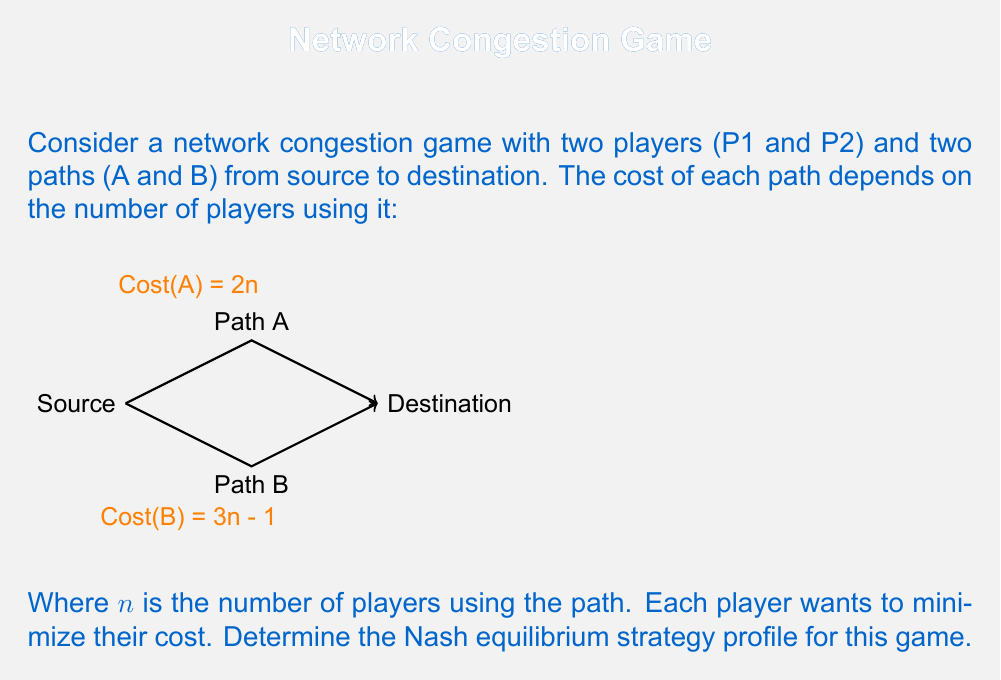Give your solution to this math problem. To find the Nash equilibrium, we need to analyze each player's best response to the other player's strategy. Let's approach this step-by-step:

1. List all possible strategy profiles:
   - (A, A): Both players choose path A
   - (A, B): P1 chooses A, P2 chooses B
   - (B, A): P1 chooses B, P2 chooses A
   - (B, B): Both players choose path B

2. Calculate the costs for each profile:
   - (A, A): Cost for each player = $2 * 2 = 4$
   - (A, B): Cost for P1 = $2 * 1 = 2$, Cost for P2 = $3 * 1 - 1 = 2$
   - (B, A): Cost for P1 = $3 * 1 - 1 = 2$, Cost for P2 = $2 * 1 = 2$
   - (B, B): Cost for each player = $3 * 2 - 1 = 5$

3. Analyze each player's best response:
   - If P2 chooses A, P1's best response is B (cost 2 vs 4)
   - If P2 chooses B, P1's best response is A (cost 2 vs 5)
   - If P1 chooses A, P2's best response is B (cost 2 vs 4)
   - If P1 chooses B, P2's best response is A (cost 2 vs 5)

4. Identify the Nash equilibrium:
   A Nash equilibrium occurs when neither player can unilaterally improve their outcome by changing their strategy. From our analysis, we can see that there are two such situations:
   - (A, B): P1 chooses A, P2 chooses B
   - (B, A): P1 chooses B, P2 chooses A

In both these cases, each player has a cost of 2, and switching to the other path would increase their cost to 4 or 5.
Answer: The Nash equilibria are (A, B) and (B, A). 